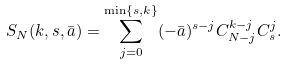Convert formula to latex. <formula><loc_0><loc_0><loc_500><loc_500>S _ { N } ( k , s , \bar { a } ) = \sum _ { j = 0 } ^ { \min \{ s , k \} } ( - \bar { a } ) ^ { s - j } C _ { N - j } ^ { k - j } C _ { s } ^ { j } .</formula> 